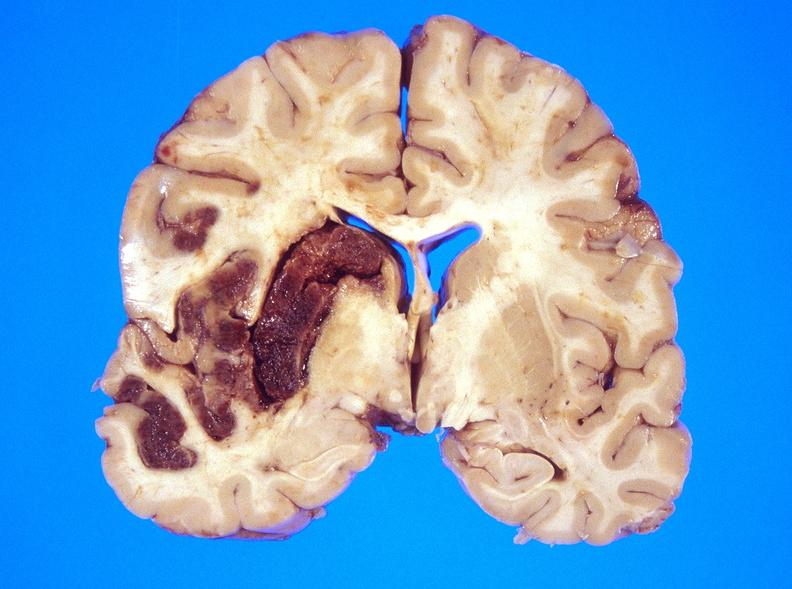s nervous present?
Answer the question using a single word or phrase. Yes 